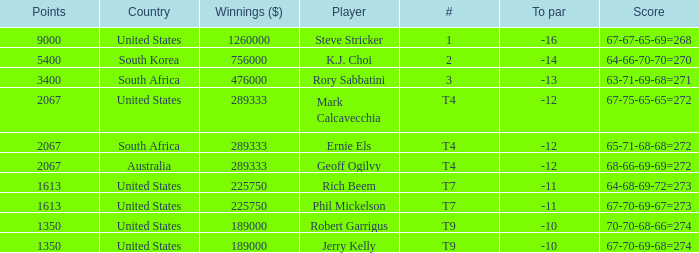Name the number of points for south korea 1.0. 